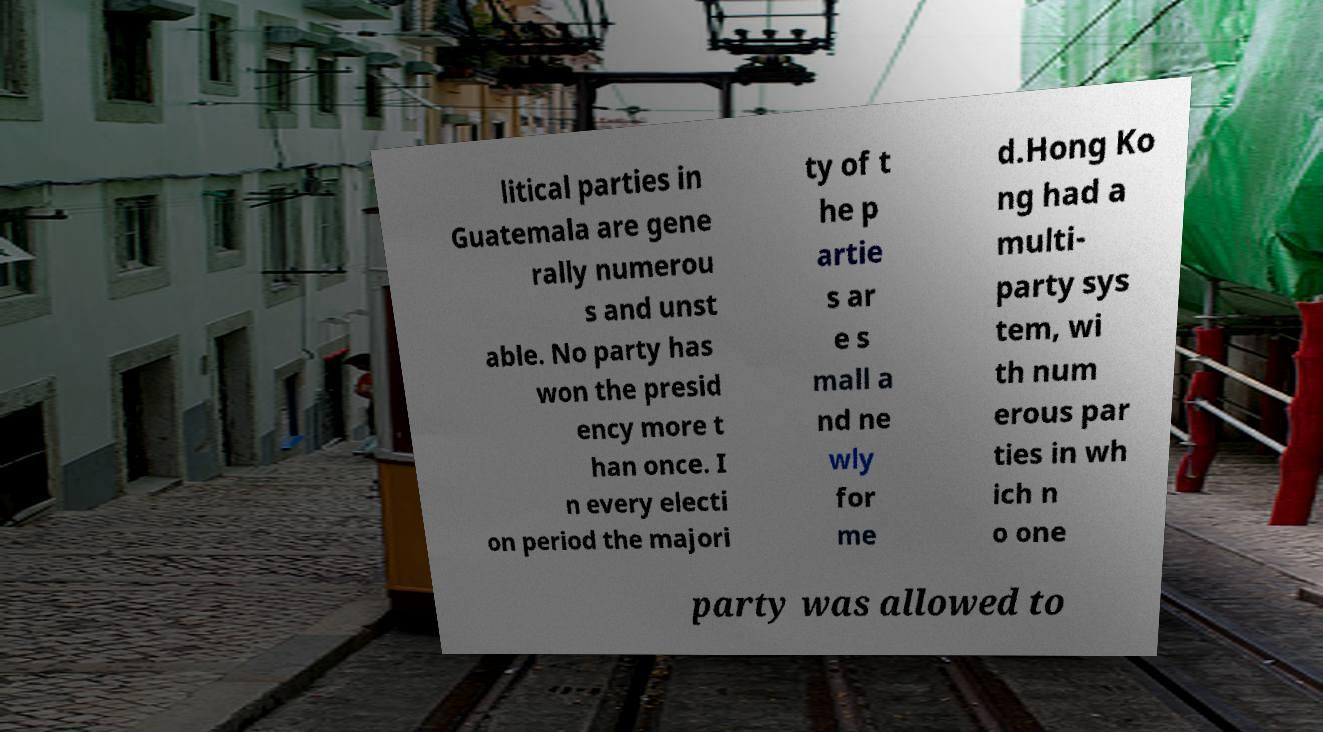Please identify and transcribe the text found in this image. litical parties in Guatemala are gene rally numerou s and unst able. No party has won the presid ency more t han once. I n every electi on period the majori ty of t he p artie s ar e s mall a nd ne wly for me d.Hong Ko ng had a multi- party sys tem, wi th num erous par ties in wh ich n o one party was allowed to 